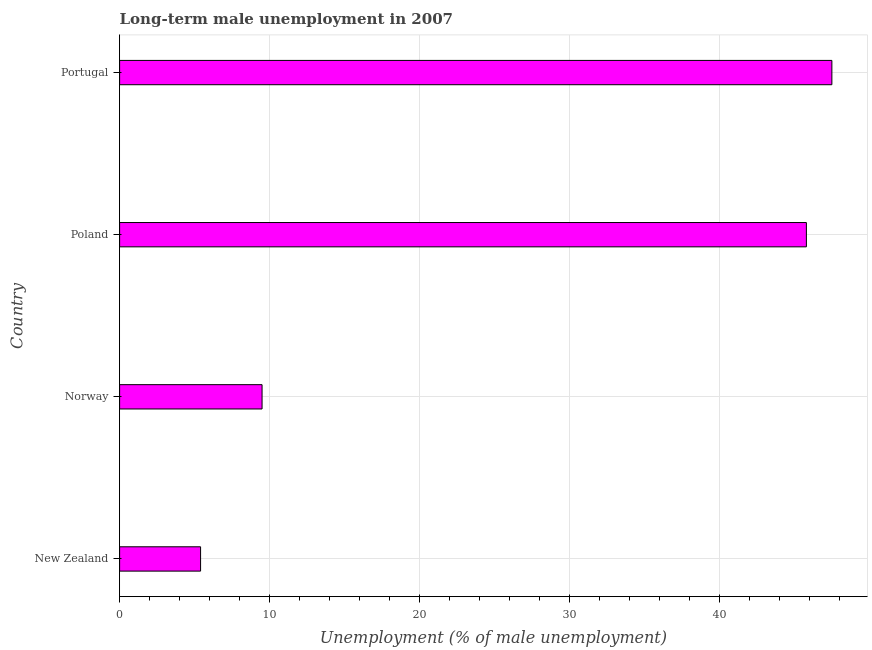What is the title of the graph?
Your answer should be compact. Long-term male unemployment in 2007. What is the label or title of the X-axis?
Offer a terse response. Unemployment (% of male unemployment). What is the long-term male unemployment in Poland?
Offer a very short reply. 45.8. Across all countries, what is the maximum long-term male unemployment?
Offer a terse response. 47.5. Across all countries, what is the minimum long-term male unemployment?
Keep it short and to the point. 5.4. In which country was the long-term male unemployment minimum?
Provide a succinct answer. New Zealand. What is the sum of the long-term male unemployment?
Your answer should be very brief. 108.2. What is the difference between the long-term male unemployment in Norway and Portugal?
Your response must be concise. -38. What is the average long-term male unemployment per country?
Your response must be concise. 27.05. What is the median long-term male unemployment?
Ensure brevity in your answer.  27.65. What is the ratio of the long-term male unemployment in New Zealand to that in Portugal?
Provide a short and direct response. 0.11. What is the difference between the highest and the second highest long-term male unemployment?
Your answer should be very brief. 1.7. What is the difference between the highest and the lowest long-term male unemployment?
Ensure brevity in your answer.  42.1. In how many countries, is the long-term male unemployment greater than the average long-term male unemployment taken over all countries?
Your answer should be very brief. 2. How many bars are there?
Your answer should be compact. 4. Are all the bars in the graph horizontal?
Provide a succinct answer. Yes. How many countries are there in the graph?
Ensure brevity in your answer.  4. What is the difference between two consecutive major ticks on the X-axis?
Your answer should be very brief. 10. What is the Unemployment (% of male unemployment) in New Zealand?
Keep it short and to the point. 5.4. What is the Unemployment (% of male unemployment) of Norway?
Offer a very short reply. 9.5. What is the Unemployment (% of male unemployment) in Poland?
Offer a terse response. 45.8. What is the Unemployment (% of male unemployment) in Portugal?
Provide a short and direct response. 47.5. What is the difference between the Unemployment (% of male unemployment) in New Zealand and Poland?
Offer a very short reply. -40.4. What is the difference between the Unemployment (% of male unemployment) in New Zealand and Portugal?
Give a very brief answer. -42.1. What is the difference between the Unemployment (% of male unemployment) in Norway and Poland?
Make the answer very short. -36.3. What is the difference between the Unemployment (% of male unemployment) in Norway and Portugal?
Your answer should be very brief. -38. What is the ratio of the Unemployment (% of male unemployment) in New Zealand to that in Norway?
Your answer should be compact. 0.57. What is the ratio of the Unemployment (% of male unemployment) in New Zealand to that in Poland?
Your answer should be very brief. 0.12. What is the ratio of the Unemployment (% of male unemployment) in New Zealand to that in Portugal?
Make the answer very short. 0.11. What is the ratio of the Unemployment (% of male unemployment) in Norway to that in Poland?
Your answer should be very brief. 0.21. What is the ratio of the Unemployment (% of male unemployment) in Poland to that in Portugal?
Your answer should be compact. 0.96. 